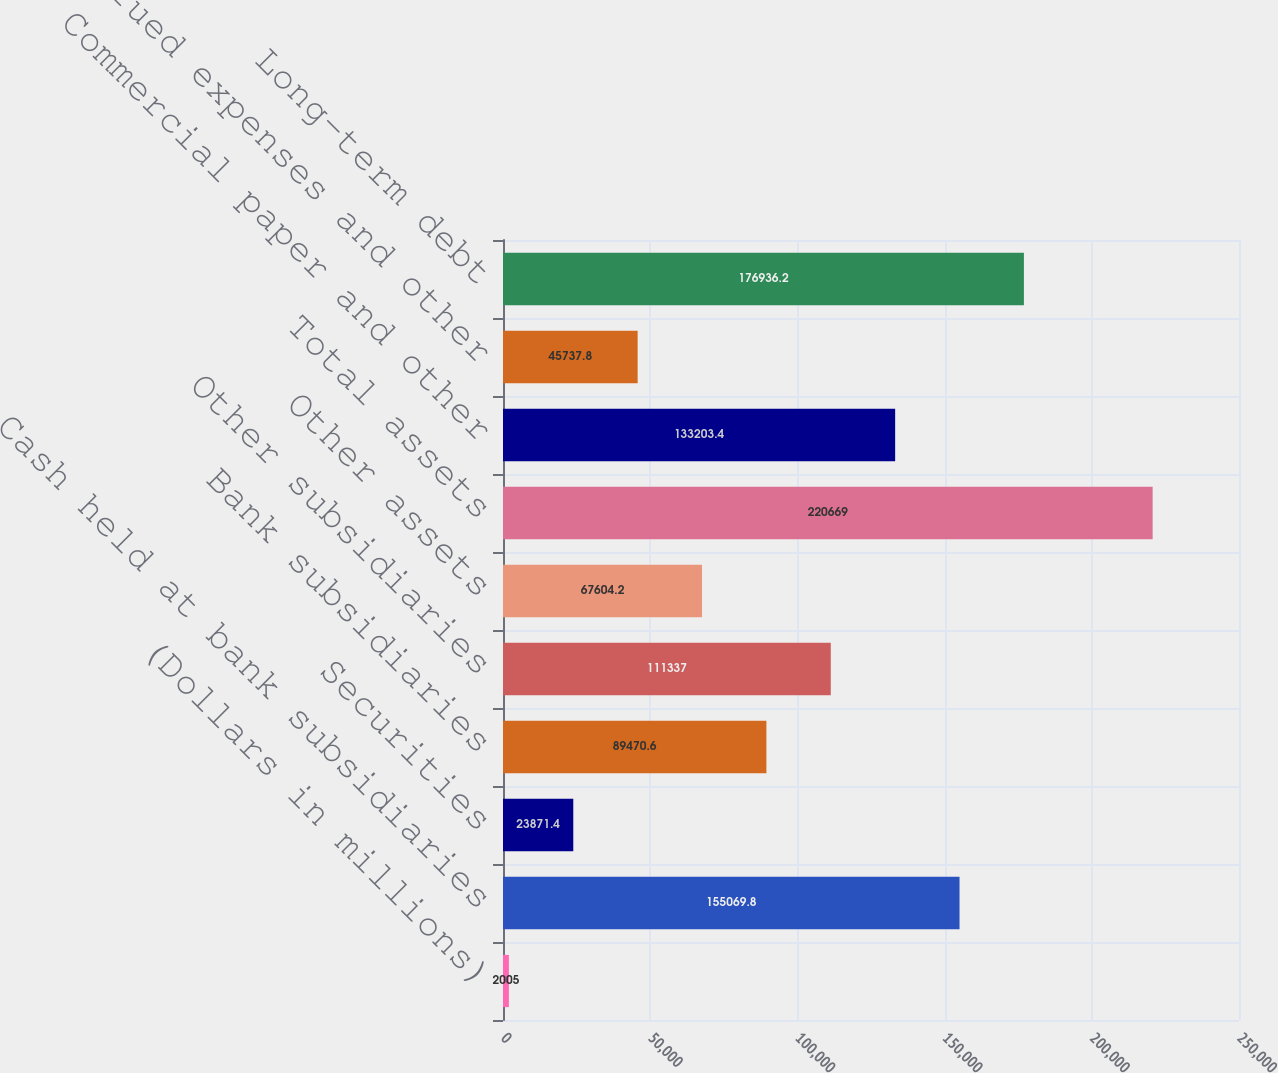Convert chart to OTSL. <chart><loc_0><loc_0><loc_500><loc_500><bar_chart><fcel>(Dollars in millions)<fcel>Cash held at bank subsidiaries<fcel>Securities<fcel>Bank subsidiaries<fcel>Other subsidiaries<fcel>Other assets<fcel>Total assets<fcel>Commercial paper and other<fcel>Accrued expenses and other<fcel>Long-term debt<nl><fcel>2005<fcel>155070<fcel>23871.4<fcel>89470.6<fcel>111337<fcel>67604.2<fcel>220669<fcel>133203<fcel>45737.8<fcel>176936<nl></chart> 